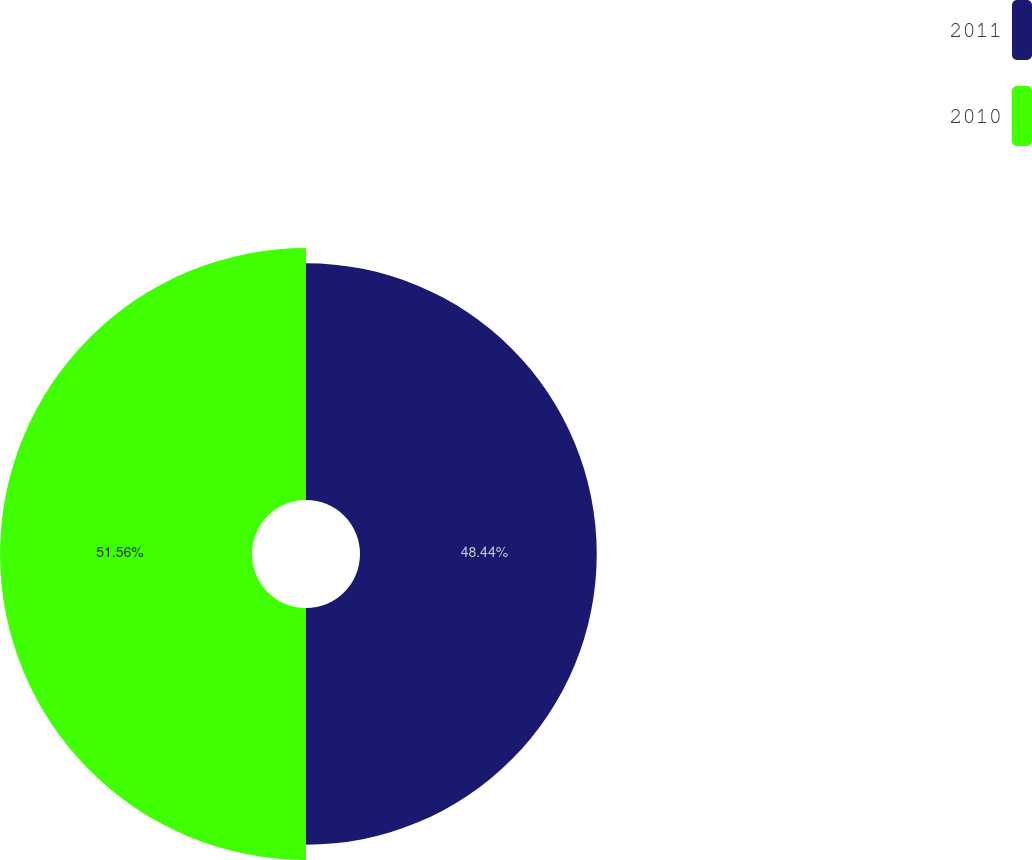Convert chart. <chart><loc_0><loc_0><loc_500><loc_500><pie_chart><fcel>2011<fcel>2010<nl><fcel>48.44%<fcel>51.56%<nl></chart> 